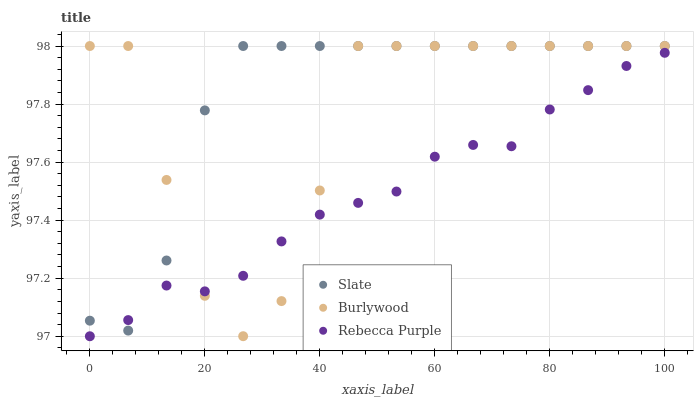Does Rebecca Purple have the minimum area under the curve?
Answer yes or no. Yes. Does Slate have the maximum area under the curve?
Answer yes or no. Yes. Does Slate have the minimum area under the curve?
Answer yes or no. No. Does Rebecca Purple have the maximum area under the curve?
Answer yes or no. No. Is Rebecca Purple the smoothest?
Answer yes or no. Yes. Is Burlywood the roughest?
Answer yes or no. Yes. Is Slate the smoothest?
Answer yes or no. No. Is Slate the roughest?
Answer yes or no. No. Does Rebecca Purple have the lowest value?
Answer yes or no. Yes. Does Slate have the lowest value?
Answer yes or no. No. Does Slate have the highest value?
Answer yes or no. Yes. Does Rebecca Purple have the highest value?
Answer yes or no. No. Does Rebecca Purple intersect Slate?
Answer yes or no. Yes. Is Rebecca Purple less than Slate?
Answer yes or no. No. Is Rebecca Purple greater than Slate?
Answer yes or no. No. 